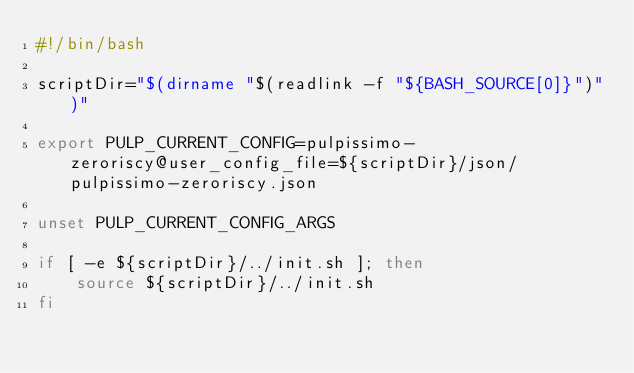<code> <loc_0><loc_0><loc_500><loc_500><_Bash_>#!/bin/bash

scriptDir="$(dirname "$(readlink -f "${BASH_SOURCE[0]}")")"

export PULP_CURRENT_CONFIG=pulpissimo-zeroriscy@user_config_file=${scriptDir}/json/pulpissimo-zeroriscy.json

unset PULP_CURRENT_CONFIG_ARGS

if [ -e ${scriptDir}/../init.sh ]; then
    source ${scriptDir}/../init.sh
fi
</code> 